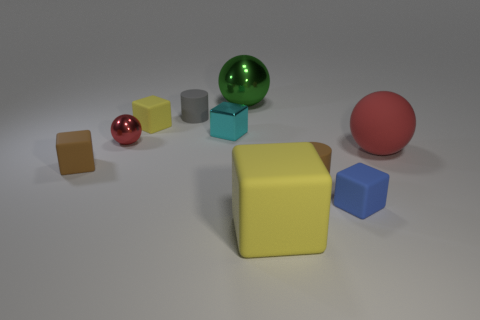Are there any other things that are the same color as the small metal block?
Provide a short and direct response. No. Is the size of the metallic sphere on the right side of the gray cylinder the same as the big yellow rubber block?
Your response must be concise. Yes. There is a shiny sphere behind the tiny cylinder behind the rubber block left of the red metallic ball; what is its color?
Provide a succinct answer. Green. What color is the large rubber cube?
Offer a very short reply. Yellow. Is the small ball the same color as the rubber sphere?
Make the answer very short. Yes. Is the material of the small cylinder that is behind the tiny yellow object the same as the big object behind the tiny yellow thing?
Provide a short and direct response. No. What is the material of the small blue object that is the same shape as the cyan thing?
Offer a terse response. Rubber. Is the big red sphere made of the same material as the tiny cyan thing?
Make the answer very short. No. There is a rubber cylinder that is on the right side of the yellow object right of the small yellow object; what is its color?
Your answer should be very brief. Brown. The red thing that is made of the same material as the big cube is what size?
Give a very brief answer. Large. 